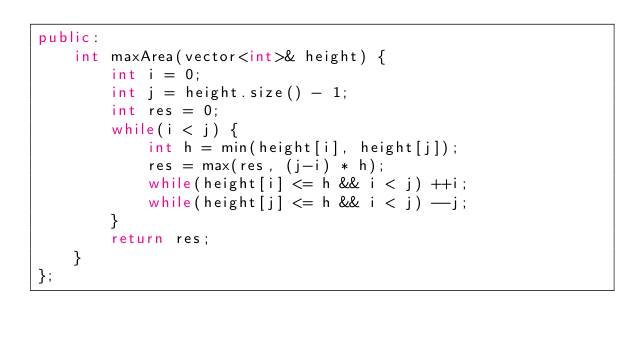<code> <loc_0><loc_0><loc_500><loc_500><_C++_>public:
    int maxArea(vector<int>& height) {
        int i = 0;
        int j = height.size() - 1;
        int res = 0;
        while(i < j) {
            int h = min(height[i], height[j]);
            res = max(res, (j-i) * h);
            while(height[i] <= h && i < j) ++i;
            while(height[j] <= h && i < j) --j;
        }
        return res;
    }
};</code> 